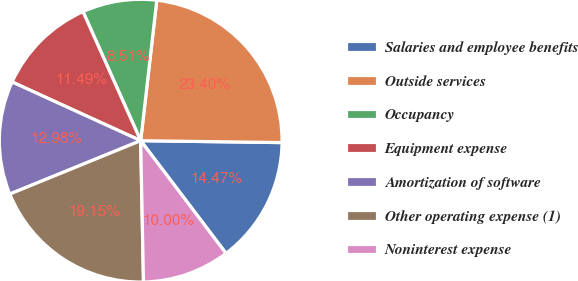Convert chart to OTSL. <chart><loc_0><loc_0><loc_500><loc_500><pie_chart><fcel>Salaries and employee benefits<fcel>Outside services<fcel>Occupancy<fcel>Equipment expense<fcel>Amortization of software<fcel>Other operating expense (1)<fcel>Noninterest expense<nl><fcel>14.47%<fcel>23.4%<fcel>8.51%<fcel>11.49%<fcel>12.98%<fcel>19.15%<fcel>10.0%<nl></chart> 